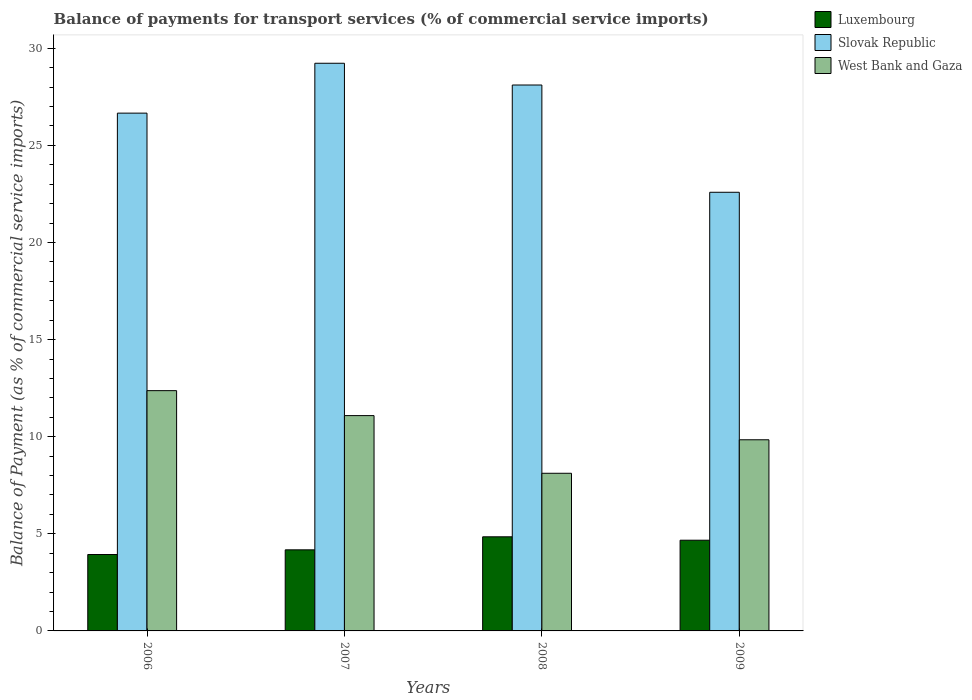Are the number of bars per tick equal to the number of legend labels?
Make the answer very short. Yes. How many bars are there on the 1st tick from the left?
Provide a succinct answer. 3. What is the balance of payments for transport services in Slovak Republic in 2008?
Offer a terse response. 28.11. Across all years, what is the maximum balance of payments for transport services in West Bank and Gaza?
Offer a terse response. 12.37. Across all years, what is the minimum balance of payments for transport services in West Bank and Gaza?
Keep it short and to the point. 8.12. In which year was the balance of payments for transport services in Slovak Republic maximum?
Keep it short and to the point. 2007. What is the total balance of payments for transport services in West Bank and Gaza in the graph?
Provide a short and direct response. 41.41. What is the difference between the balance of payments for transport services in Luxembourg in 2007 and that in 2009?
Your answer should be compact. -0.5. What is the difference between the balance of payments for transport services in Luxembourg in 2007 and the balance of payments for transport services in Slovak Republic in 2006?
Provide a succinct answer. -22.48. What is the average balance of payments for transport services in West Bank and Gaza per year?
Your answer should be very brief. 10.35. In the year 2006, what is the difference between the balance of payments for transport services in Luxembourg and balance of payments for transport services in West Bank and Gaza?
Make the answer very short. -8.44. What is the ratio of the balance of payments for transport services in Luxembourg in 2006 to that in 2008?
Keep it short and to the point. 0.81. Is the balance of payments for transport services in Slovak Republic in 2008 less than that in 2009?
Ensure brevity in your answer.  No. What is the difference between the highest and the second highest balance of payments for transport services in Slovak Republic?
Provide a short and direct response. 1.12. What is the difference between the highest and the lowest balance of payments for transport services in Luxembourg?
Your response must be concise. 0.91. Is the sum of the balance of payments for transport services in Luxembourg in 2007 and 2008 greater than the maximum balance of payments for transport services in Slovak Republic across all years?
Make the answer very short. No. What does the 3rd bar from the left in 2007 represents?
Ensure brevity in your answer.  West Bank and Gaza. What does the 3rd bar from the right in 2007 represents?
Offer a very short reply. Luxembourg. Is it the case that in every year, the sum of the balance of payments for transport services in West Bank and Gaza and balance of payments for transport services in Luxembourg is greater than the balance of payments for transport services in Slovak Republic?
Offer a terse response. No. What is the difference between two consecutive major ticks on the Y-axis?
Your answer should be very brief. 5. Where does the legend appear in the graph?
Your response must be concise. Top right. How many legend labels are there?
Make the answer very short. 3. How are the legend labels stacked?
Make the answer very short. Vertical. What is the title of the graph?
Your response must be concise. Balance of payments for transport services (% of commercial service imports). Does "Austria" appear as one of the legend labels in the graph?
Your response must be concise. No. What is the label or title of the Y-axis?
Ensure brevity in your answer.  Balance of Payment (as % of commercial service imports). What is the Balance of Payment (as % of commercial service imports) in Luxembourg in 2006?
Offer a terse response. 3.93. What is the Balance of Payment (as % of commercial service imports) of Slovak Republic in 2006?
Your answer should be compact. 26.66. What is the Balance of Payment (as % of commercial service imports) in West Bank and Gaza in 2006?
Give a very brief answer. 12.37. What is the Balance of Payment (as % of commercial service imports) of Luxembourg in 2007?
Offer a very short reply. 4.17. What is the Balance of Payment (as % of commercial service imports) of Slovak Republic in 2007?
Your answer should be compact. 29.23. What is the Balance of Payment (as % of commercial service imports) in West Bank and Gaza in 2007?
Make the answer very short. 11.09. What is the Balance of Payment (as % of commercial service imports) in Luxembourg in 2008?
Keep it short and to the point. 4.85. What is the Balance of Payment (as % of commercial service imports) of Slovak Republic in 2008?
Make the answer very short. 28.11. What is the Balance of Payment (as % of commercial service imports) in West Bank and Gaza in 2008?
Give a very brief answer. 8.12. What is the Balance of Payment (as % of commercial service imports) of Luxembourg in 2009?
Your response must be concise. 4.67. What is the Balance of Payment (as % of commercial service imports) in Slovak Republic in 2009?
Your answer should be compact. 22.58. What is the Balance of Payment (as % of commercial service imports) of West Bank and Gaza in 2009?
Offer a terse response. 9.84. Across all years, what is the maximum Balance of Payment (as % of commercial service imports) in Luxembourg?
Provide a succinct answer. 4.85. Across all years, what is the maximum Balance of Payment (as % of commercial service imports) of Slovak Republic?
Give a very brief answer. 29.23. Across all years, what is the maximum Balance of Payment (as % of commercial service imports) in West Bank and Gaza?
Provide a succinct answer. 12.37. Across all years, what is the minimum Balance of Payment (as % of commercial service imports) in Luxembourg?
Make the answer very short. 3.93. Across all years, what is the minimum Balance of Payment (as % of commercial service imports) of Slovak Republic?
Provide a succinct answer. 22.58. Across all years, what is the minimum Balance of Payment (as % of commercial service imports) in West Bank and Gaza?
Offer a terse response. 8.12. What is the total Balance of Payment (as % of commercial service imports) of Luxembourg in the graph?
Make the answer very short. 17.62. What is the total Balance of Payment (as % of commercial service imports) in Slovak Republic in the graph?
Provide a short and direct response. 106.58. What is the total Balance of Payment (as % of commercial service imports) of West Bank and Gaza in the graph?
Provide a short and direct response. 41.41. What is the difference between the Balance of Payment (as % of commercial service imports) in Luxembourg in 2006 and that in 2007?
Your response must be concise. -0.24. What is the difference between the Balance of Payment (as % of commercial service imports) in Slovak Republic in 2006 and that in 2007?
Keep it short and to the point. -2.57. What is the difference between the Balance of Payment (as % of commercial service imports) in West Bank and Gaza in 2006 and that in 2007?
Offer a very short reply. 1.28. What is the difference between the Balance of Payment (as % of commercial service imports) in Luxembourg in 2006 and that in 2008?
Provide a short and direct response. -0.91. What is the difference between the Balance of Payment (as % of commercial service imports) of Slovak Republic in 2006 and that in 2008?
Your answer should be compact. -1.45. What is the difference between the Balance of Payment (as % of commercial service imports) in West Bank and Gaza in 2006 and that in 2008?
Offer a terse response. 4.25. What is the difference between the Balance of Payment (as % of commercial service imports) of Luxembourg in 2006 and that in 2009?
Offer a very short reply. -0.74. What is the difference between the Balance of Payment (as % of commercial service imports) of Slovak Republic in 2006 and that in 2009?
Your answer should be compact. 4.08. What is the difference between the Balance of Payment (as % of commercial service imports) in West Bank and Gaza in 2006 and that in 2009?
Offer a terse response. 2.53. What is the difference between the Balance of Payment (as % of commercial service imports) in Luxembourg in 2007 and that in 2008?
Provide a succinct answer. -0.67. What is the difference between the Balance of Payment (as % of commercial service imports) of Slovak Republic in 2007 and that in 2008?
Provide a short and direct response. 1.12. What is the difference between the Balance of Payment (as % of commercial service imports) of West Bank and Gaza in 2007 and that in 2008?
Your answer should be very brief. 2.97. What is the difference between the Balance of Payment (as % of commercial service imports) of Luxembourg in 2007 and that in 2009?
Keep it short and to the point. -0.5. What is the difference between the Balance of Payment (as % of commercial service imports) of Slovak Republic in 2007 and that in 2009?
Offer a very short reply. 6.64. What is the difference between the Balance of Payment (as % of commercial service imports) in West Bank and Gaza in 2007 and that in 2009?
Your answer should be very brief. 1.24. What is the difference between the Balance of Payment (as % of commercial service imports) of Luxembourg in 2008 and that in 2009?
Your answer should be compact. 0.18. What is the difference between the Balance of Payment (as % of commercial service imports) in Slovak Republic in 2008 and that in 2009?
Your response must be concise. 5.52. What is the difference between the Balance of Payment (as % of commercial service imports) of West Bank and Gaza in 2008 and that in 2009?
Your answer should be compact. -1.72. What is the difference between the Balance of Payment (as % of commercial service imports) of Luxembourg in 2006 and the Balance of Payment (as % of commercial service imports) of Slovak Republic in 2007?
Give a very brief answer. -25.29. What is the difference between the Balance of Payment (as % of commercial service imports) in Luxembourg in 2006 and the Balance of Payment (as % of commercial service imports) in West Bank and Gaza in 2007?
Provide a short and direct response. -7.15. What is the difference between the Balance of Payment (as % of commercial service imports) of Slovak Republic in 2006 and the Balance of Payment (as % of commercial service imports) of West Bank and Gaza in 2007?
Give a very brief answer. 15.57. What is the difference between the Balance of Payment (as % of commercial service imports) of Luxembourg in 2006 and the Balance of Payment (as % of commercial service imports) of Slovak Republic in 2008?
Offer a terse response. -24.17. What is the difference between the Balance of Payment (as % of commercial service imports) in Luxembourg in 2006 and the Balance of Payment (as % of commercial service imports) in West Bank and Gaza in 2008?
Your answer should be very brief. -4.18. What is the difference between the Balance of Payment (as % of commercial service imports) in Slovak Republic in 2006 and the Balance of Payment (as % of commercial service imports) in West Bank and Gaza in 2008?
Keep it short and to the point. 18.54. What is the difference between the Balance of Payment (as % of commercial service imports) in Luxembourg in 2006 and the Balance of Payment (as % of commercial service imports) in Slovak Republic in 2009?
Keep it short and to the point. -18.65. What is the difference between the Balance of Payment (as % of commercial service imports) in Luxembourg in 2006 and the Balance of Payment (as % of commercial service imports) in West Bank and Gaza in 2009?
Ensure brevity in your answer.  -5.91. What is the difference between the Balance of Payment (as % of commercial service imports) of Slovak Republic in 2006 and the Balance of Payment (as % of commercial service imports) of West Bank and Gaza in 2009?
Make the answer very short. 16.82. What is the difference between the Balance of Payment (as % of commercial service imports) in Luxembourg in 2007 and the Balance of Payment (as % of commercial service imports) in Slovak Republic in 2008?
Ensure brevity in your answer.  -23.93. What is the difference between the Balance of Payment (as % of commercial service imports) in Luxembourg in 2007 and the Balance of Payment (as % of commercial service imports) in West Bank and Gaza in 2008?
Ensure brevity in your answer.  -3.94. What is the difference between the Balance of Payment (as % of commercial service imports) of Slovak Republic in 2007 and the Balance of Payment (as % of commercial service imports) of West Bank and Gaza in 2008?
Offer a terse response. 21.11. What is the difference between the Balance of Payment (as % of commercial service imports) of Luxembourg in 2007 and the Balance of Payment (as % of commercial service imports) of Slovak Republic in 2009?
Provide a succinct answer. -18.41. What is the difference between the Balance of Payment (as % of commercial service imports) of Luxembourg in 2007 and the Balance of Payment (as % of commercial service imports) of West Bank and Gaza in 2009?
Provide a short and direct response. -5.67. What is the difference between the Balance of Payment (as % of commercial service imports) of Slovak Republic in 2007 and the Balance of Payment (as % of commercial service imports) of West Bank and Gaza in 2009?
Provide a succinct answer. 19.39. What is the difference between the Balance of Payment (as % of commercial service imports) of Luxembourg in 2008 and the Balance of Payment (as % of commercial service imports) of Slovak Republic in 2009?
Keep it short and to the point. -17.74. What is the difference between the Balance of Payment (as % of commercial service imports) in Luxembourg in 2008 and the Balance of Payment (as % of commercial service imports) in West Bank and Gaza in 2009?
Your response must be concise. -5. What is the difference between the Balance of Payment (as % of commercial service imports) of Slovak Republic in 2008 and the Balance of Payment (as % of commercial service imports) of West Bank and Gaza in 2009?
Your answer should be very brief. 18.27. What is the average Balance of Payment (as % of commercial service imports) in Luxembourg per year?
Your answer should be very brief. 4.41. What is the average Balance of Payment (as % of commercial service imports) of Slovak Republic per year?
Give a very brief answer. 26.64. What is the average Balance of Payment (as % of commercial service imports) in West Bank and Gaza per year?
Ensure brevity in your answer.  10.35. In the year 2006, what is the difference between the Balance of Payment (as % of commercial service imports) of Luxembourg and Balance of Payment (as % of commercial service imports) of Slovak Republic?
Ensure brevity in your answer.  -22.72. In the year 2006, what is the difference between the Balance of Payment (as % of commercial service imports) of Luxembourg and Balance of Payment (as % of commercial service imports) of West Bank and Gaza?
Your answer should be compact. -8.44. In the year 2006, what is the difference between the Balance of Payment (as % of commercial service imports) of Slovak Republic and Balance of Payment (as % of commercial service imports) of West Bank and Gaza?
Offer a very short reply. 14.29. In the year 2007, what is the difference between the Balance of Payment (as % of commercial service imports) in Luxembourg and Balance of Payment (as % of commercial service imports) in Slovak Republic?
Keep it short and to the point. -25.05. In the year 2007, what is the difference between the Balance of Payment (as % of commercial service imports) in Luxembourg and Balance of Payment (as % of commercial service imports) in West Bank and Gaza?
Keep it short and to the point. -6.91. In the year 2007, what is the difference between the Balance of Payment (as % of commercial service imports) in Slovak Republic and Balance of Payment (as % of commercial service imports) in West Bank and Gaza?
Provide a succinct answer. 18.14. In the year 2008, what is the difference between the Balance of Payment (as % of commercial service imports) of Luxembourg and Balance of Payment (as % of commercial service imports) of Slovak Republic?
Provide a short and direct response. -23.26. In the year 2008, what is the difference between the Balance of Payment (as % of commercial service imports) of Luxembourg and Balance of Payment (as % of commercial service imports) of West Bank and Gaza?
Provide a succinct answer. -3.27. In the year 2008, what is the difference between the Balance of Payment (as % of commercial service imports) in Slovak Republic and Balance of Payment (as % of commercial service imports) in West Bank and Gaza?
Your answer should be compact. 19.99. In the year 2009, what is the difference between the Balance of Payment (as % of commercial service imports) of Luxembourg and Balance of Payment (as % of commercial service imports) of Slovak Republic?
Provide a short and direct response. -17.91. In the year 2009, what is the difference between the Balance of Payment (as % of commercial service imports) in Luxembourg and Balance of Payment (as % of commercial service imports) in West Bank and Gaza?
Provide a succinct answer. -5.17. In the year 2009, what is the difference between the Balance of Payment (as % of commercial service imports) in Slovak Republic and Balance of Payment (as % of commercial service imports) in West Bank and Gaza?
Offer a very short reply. 12.74. What is the ratio of the Balance of Payment (as % of commercial service imports) of Luxembourg in 2006 to that in 2007?
Give a very brief answer. 0.94. What is the ratio of the Balance of Payment (as % of commercial service imports) in Slovak Republic in 2006 to that in 2007?
Offer a very short reply. 0.91. What is the ratio of the Balance of Payment (as % of commercial service imports) of West Bank and Gaza in 2006 to that in 2007?
Your response must be concise. 1.12. What is the ratio of the Balance of Payment (as % of commercial service imports) in Luxembourg in 2006 to that in 2008?
Keep it short and to the point. 0.81. What is the ratio of the Balance of Payment (as % of commercial service imports) of Slovak Republic in 2006 to that in 2008?
Provide a succinct answer. 0.95. What is the ratio of the Balance of Payment (as % of commercial service imports) in West Bank and Gaza in 2006 to that in 2008?
Your answer should be compact. 1.52. What is the ratio of the Balance of Payment (as % of commercial service imports) of Luxembourg in 2006 to that in 2009?
Make the answer very short. 0.84. What is the ratio of the Balance of Payment (as % of commercial service imports) in Slovak Republic in 2006 to that in 2009?
Offer a very short reply. 1.18. What is the ratio of the Balance of Payment (as % of commercial service imports) in West Bank and Gaza in 2006 to that in 2009?
Offer a very short reply. 1.26. What is the ratio of the Balance of Payment (as % of commercial service imports) in Luxembourg in 2007 to that in 2008?
Your answer should be compact. 0.86. What is the ratio of the Balance of Payment (as % of commercial service imports) in Slovak Republic in 2007 to that in 2008?
Your answer should be very brief. 1.04. What is the ratio of the Balance of Payment (as % of commercial service imports) of West Bank and Gaza in 2007 to that in 2008?
Provide a succinct answer. 1.37. What is the ratio of the Balance of Payment (as % of commercial service imports) in Luxembourg in 2007 to that in 2009?
Offer a terse response. 0.89. What is the ratio of the Balance of Payment (as % of commercial service imports) in Slovak Republic in 2007 to that in 2009?
Your answer should be compact. 1.29. What is the ratio of the Balance of Payment (as % of commercial service imports) of West Bank and Gaza in 2007 to that in 2009?
Make the answer very short. 1.13. What is the ratio of the Balance of Payment (as % of commercial service imports) in Luxembourg in 2008 to that in 2009?
Provide a succinct answer. 1.04. What is the ratio of the Balance of Payment (as % of commercial service imports) in Slovak Republic in 2008 to that in 2009?
Provide a succinct answer. 1.24. What is the ratio of the Balance of Payment (as % of commercial service imports) in West Bank and Gaza in 2008 to that in 2009?
Provide a short and direct response. 0.82. What is the difference between the highest and the second highest Balance of Payment (as % of commercial service imports) of Luxembourg?
Make the answer very short. 0.18. What is the difference between the highest and the second highest Balance of Payment (as % of commercial service imports) of Slovak Republic?
Your answer should be compact. 1.12. What is the difference between the highest and the second highest Balance of Payment (as % of commercial service imports) in West Bank and Gaza?
Your answer should be compact. 1.28. What is the difference between the highest and the lowest Balance of Payment (as % of commercial service imports) in Luxembourg?
Give a very brief answer. 0.91. What is the difference between the highest and the lowest Balance of Payment (as % of commercial service imports) in Slovak Republic?
Your answer should be very brief. 6.64. What is the difference between the highest and the lowest Balance of Payment (as % of commercial service imports) of West Bank and Gaza?
Provide a short and direct response. 4.25. 